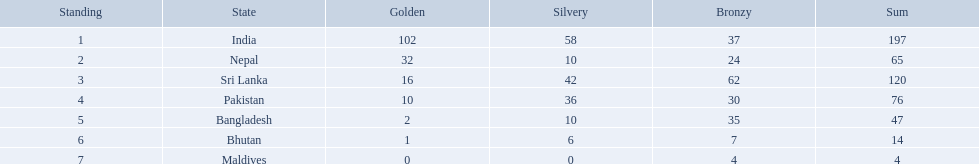Which countries won medals? India, Nepal, Sri Lanka, Pakistan, Bangladesh, Bhutan, Maldives. Which won the most? India. Which won the fewest? Maldives. What are the totals of medals one in each country? 197, 65, 120, 76, 47, 14, 4. Which of these totals are less than 10? 4. Who won this number of medals? Maldives. What were the total amount won of medals by nations in the 1999 south asian games? 197, 65, 120, 76, 47, 14, 4. Which amount was the lowest? 4. Which nation had this amount? Maldives. What nations took part in 1999 south asian games? India, Nepal, Sri Lanka, Pakistan, Bangladesh, Bhutan, Maldives. Of those who earned gold medals? India, Nepal, Sri Lanka, Pakistan, Bangladesh, Bhutan. Which nation didn't earn any gold medals? Maldives. What are the nations? India, Nepal, Sri Lanka, Pakistan, Bangladesh, Bhutan, Maldives. Of these, which one has earned the least amount of gold medals? Maldives. How many gold medals were won by the teams? 102, 32, 16, 10, 2, 1, 0. Parse the full table in json format. {'header': ['Standing', 'State', 'Golden', 'Silvery', 'Bronzy', 'Sum'], 'rows': [['1', 'India', '102', '58', '37', '197'], ['2', 'Nepal', '32', '10', '24', '65'], ['3', 'Sri Lanka', '16', '42', '62', '120'], ['4', 'Pakistan', '10', '36', '30', '76'], ['5', 'Bangladesh', '2', '10', '35', '47'], ['6', 'Bhutan', '1', '6', '7', '14'], ['7', 'Maldives', '0', '0', '4', '4']]} What country won no gold medals? Maldives. What countries attended the 1999 south asian games? India, Nepal, Sri Lanka, Pakistan, Bangladesh, Bhutan, Maldives. Which of these countries had 32 gold medals? Nepal. Which nations played at the 1999 south asian games? India, Nepal, Sri Lanka, Pakistan, Bangladesh, Bhutan, Maldives. Which country is listed second in the table? Nepal. 